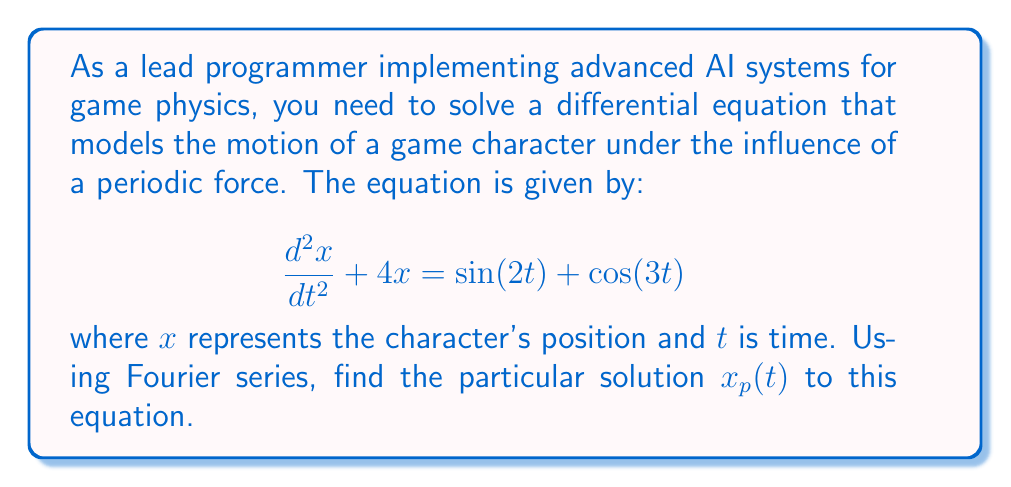Teach me how to tackle this problem. To solve this differential equation using Fourier series, we follow these steps:

1) First, we recognize that the right-hand side of the equation is already in the form of a Fourier series (a sum of sines and cosines).

2) We assume a particular solution of the form:

   $$x_p(t) = A\sin(2t) + B\cos(2t) + C\sin(3t) + D\cos(3t)$$

   where $A$, $B$, $C$, and $D$ are constants we need to determine.

3) We calculate the second derivative of $x_p(t)$:

   $$\frac{d^2x_p}{dt^2} = -4A\sin(2t) - 4B\cos(2t) - 9C\sin(3t) - 9D\cos(3t)$$

4) Substitute $x_p(t)$ and its second derivative into the original equation:

   $$(-4A\sin(2t) - 4B\cos(2t) - 9C\sin(3t) - 9D\cos(3t)) + 4(A\sin(2t) + B\cos(2t) + C\sin(3t) + D\cos(3t)) = \sin(2t) + \cos(3t)$$

5) Simplify:

   $$(-4A+4A)\sin(2t) + (-4B+4B)\cos(2t) + (-9C+4C)\sin(3t) + (-9D+4D)\cos(3t) = \sin(2t) + \cos(3t)$$

6) Equate coefficients:

   $\sin(2t)$: $0 = 1$, so $A = \frac{1}{0} = \infty$ (undefined)
   $\cos(2t)$: $0 = 0$, so $B$ can be any value
   $\sin(3t)$: $-5C = 0$, so $C = 0$
   $\cos(3t)$: $-5D = 1$, so $D = -\frac{1}{5}$

7) The coefficient $A$ is undefined because $\sin(2t)$ is a solution to the homogeneous equation. We can remove this term from our particular solution.

8) We can choose $B=0$ for simplicity.

Therefore, the particular solution is:

$$x_p(t) = -\frac{1}{5}\cos(3t)$$

This solution represents the steady-state response of the game character to the periodic force, which is crucial for realistic physics simulations in game development.
Answer: $$x_p(t) = -\frac{1}{5}\cos(3t)$$ 